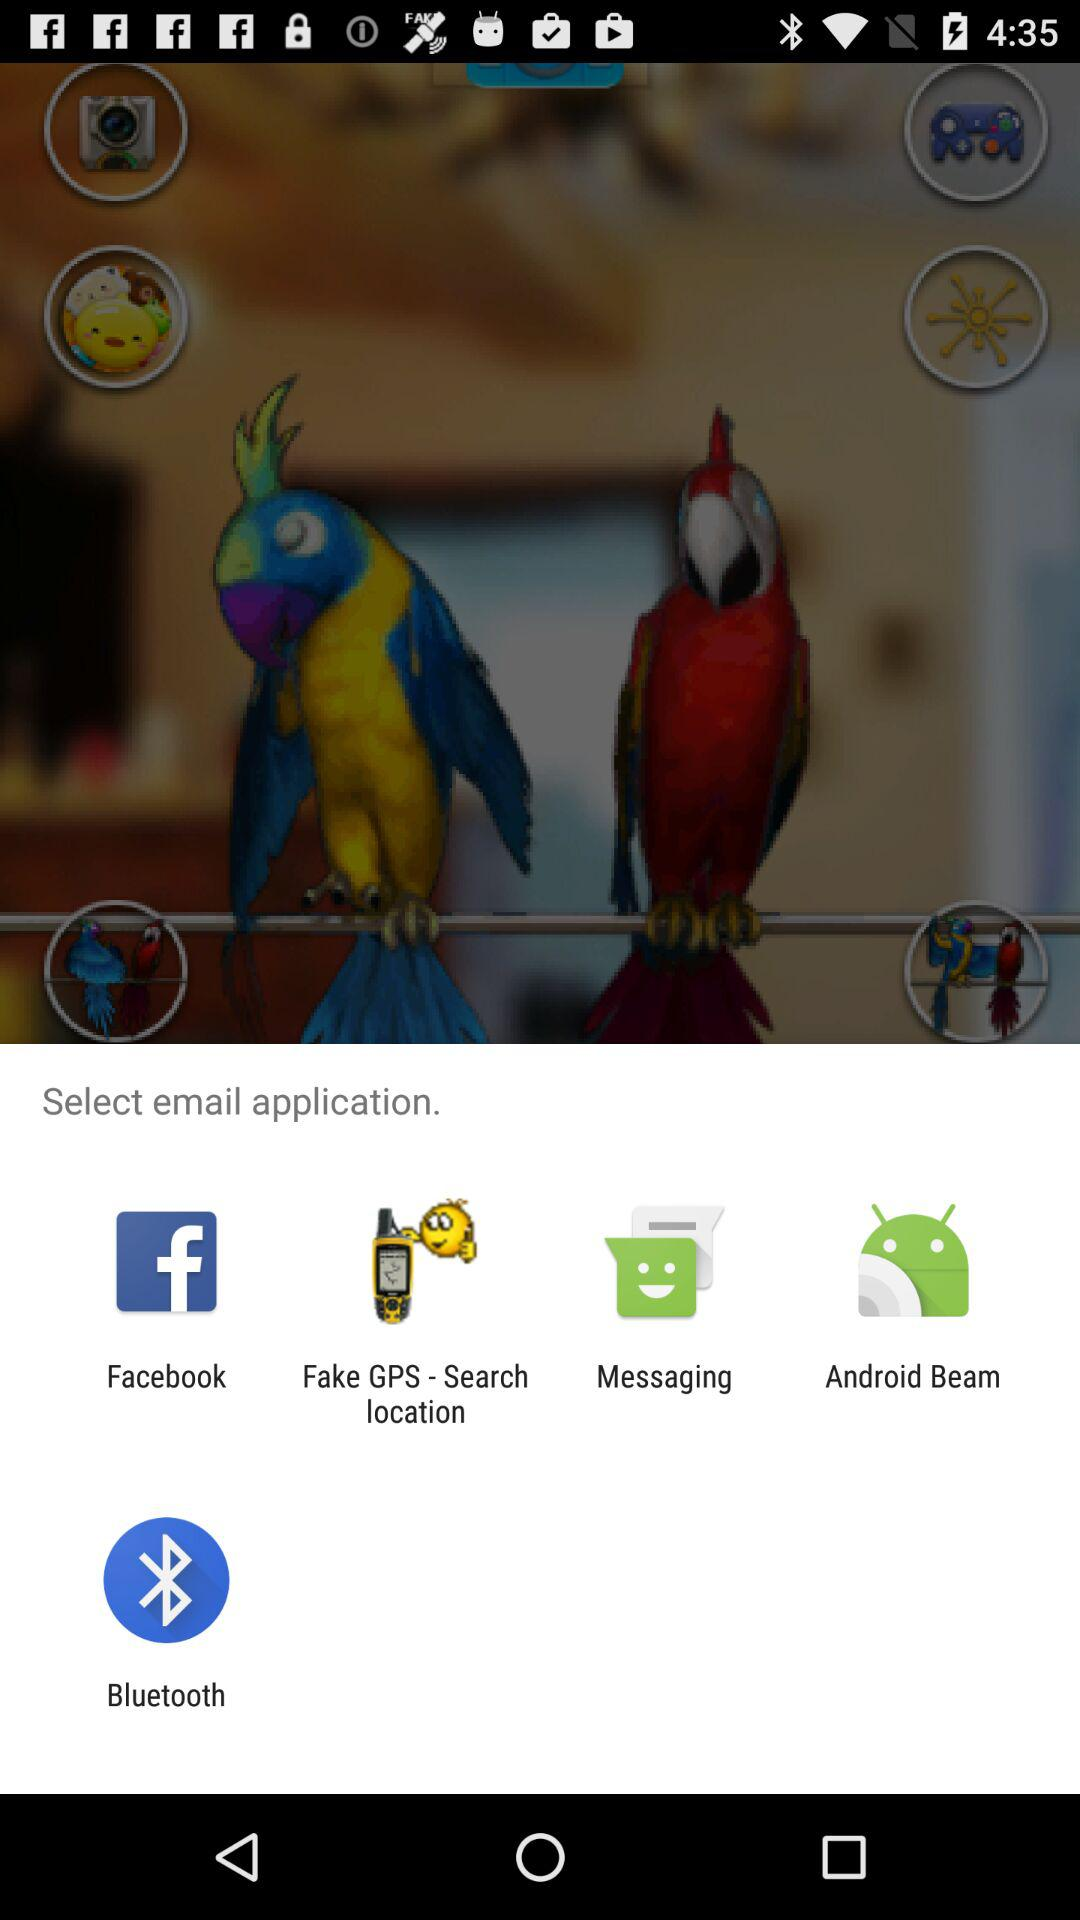What applications can be used to select email addresses? The applications are "Facebook", "Fake GPS-Search location", "Messaging", "Android Beam", and "Bluetooth". 